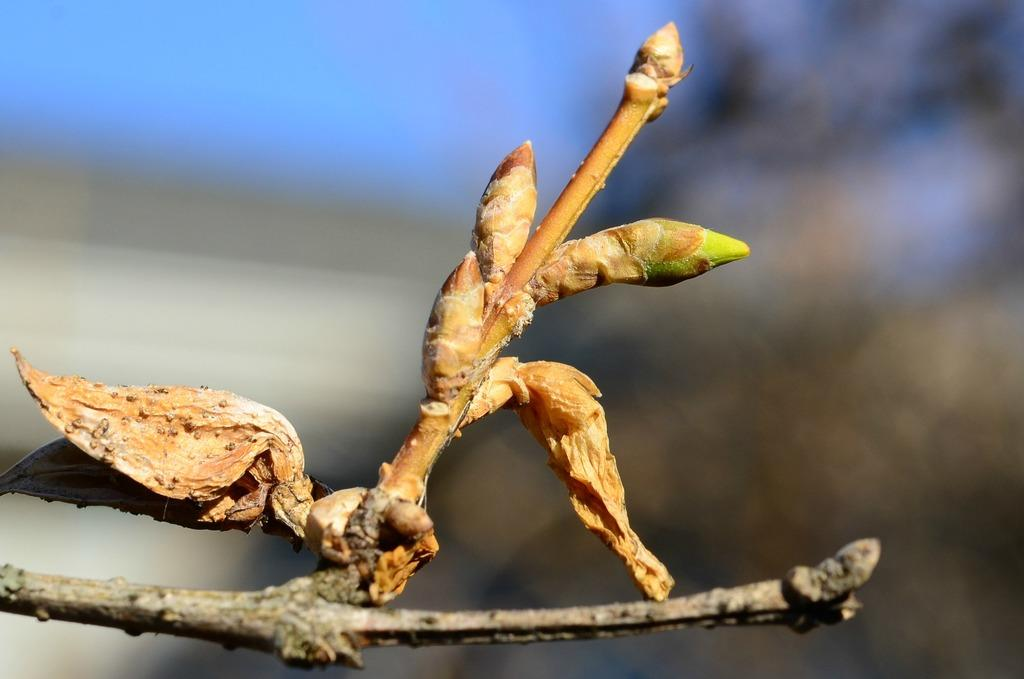What is present on the branch in the image? There are buds and dry leaves on the branch in the image. Can you describe the state of the buds? The buds are present on the branch, indicating that they are in the process of developing into leaves or flowers. What is the condition of the dry leaves on the branch? The dry leaves are present on the branch, suggesting that they are no longer functional and may fall off soon. What type of grandmother can be seen sitting on the branch in the image? There is no grandmother present in the image; it only features a branch with buds and dry leaves. 